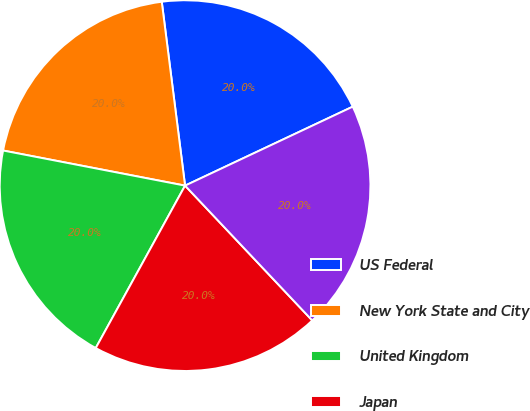<chart> <loc_0><loc_0><loc_500><loc_500><pie_chart><fcel>US Federal<fcel>New York State and City<fcel>United Kingdom<fcel>Japan<fcel>Hong Kong<nl><fcel>20.0%<fcel>19.96%<fcel>20.03%<fcel>20.04%<fcel>19.97%<nl></chart> 